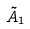Convert formula to latex. <formula><loc_0><loc_0><loc_500><loc_500>\tilde { A } _ { 1 }</formula> 